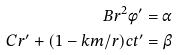Convert formula to latex. <formula><loc_0><loc_0><loc_500><loc_500>B r ^ { 2 } \phi ^ { \prime } = \alpha \\ C r ^ { \prime } + ( 1 - k m / r ) c t ^ { \prime } = \beta</formula> 